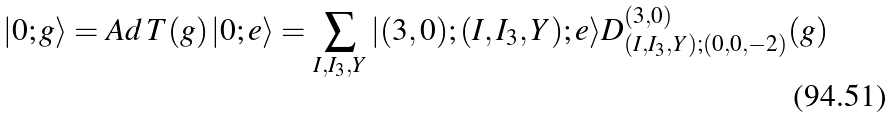<formula> <loc_0><loc_0><loc_500><loc_500>| 0 ; g \rangle = A d \, T ( g ) \, | 0 ; e \rangle = \sum _ { I , I _ { 3 } , Y } | ( 3 , 0 ) ; ( I , I _ { 3 } , Y ) ; e \rangle D _ { ( I , I _ { 3 } , Y ) ; ( 0 , 0 , - 2 ) } ^ { ( 3 , 0 ) } ( g )</formula> 